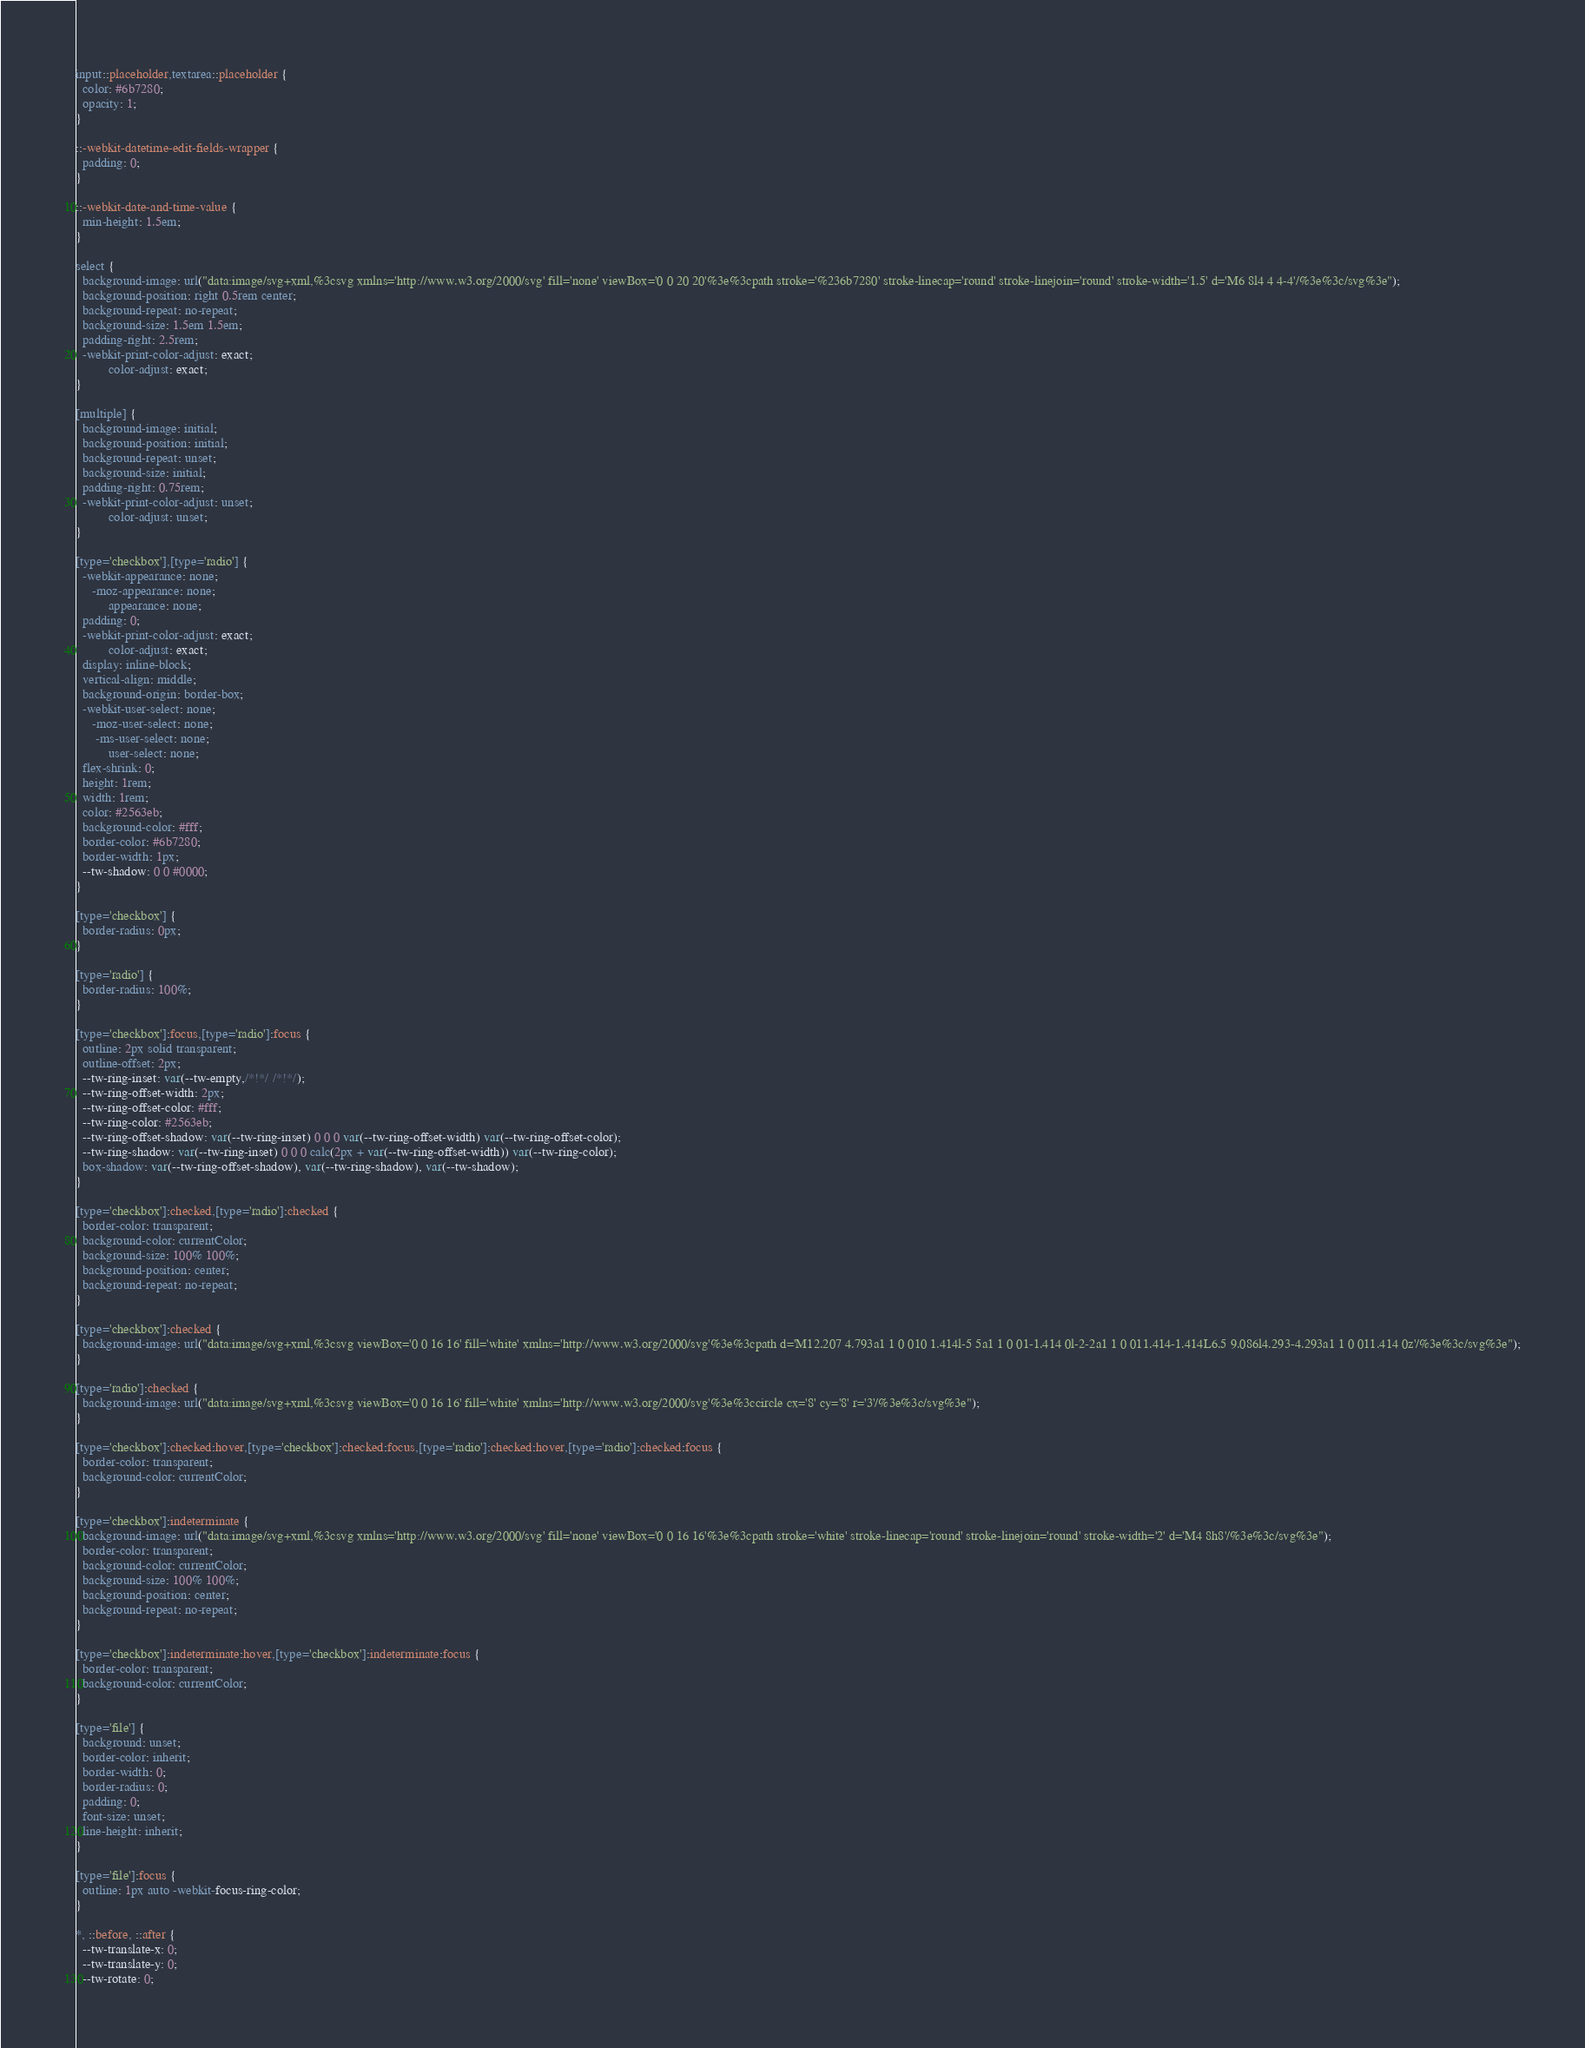Convert code to text. <code><loc_0><loc_0><loc_500><loc_500><_CSS_>
input::placeholder,textarea::placeholder {
  color: #6b7280;
  opacity: 1;
}

::-webkit-datetime-edit-fields-wrapper {
  padding: 0;
}

::-webkit-date-and-time-value {
  min-height: 1.5em;
}

select {
  background-image: url("data:image/svg+xml,%3csvg xmlns='http://www.w3.org/2000/svg' fill='none' viewBox='0 0 20 20'%3e%3cpath stroke='%236b7280' stroke-linecap='round' stroke-linejoin='round' stroke-width='1.5' d='M6 8l4 4 4-4'/%3e%3c/svg%3e");
  background-position: right 0.5rem center;
  background-repeat: no-repeat;
  background-size: 1.5em 1.5em;
  padding-right: 2.5rem;
  -webkit-print-color-adjust: exact;
          color-adjust: exact;
}

[multiple] {
  background-image: initial;
  background-position: initial;
  background-repeat: unset;
  background-size: initial;
  padding-right: 0.75rem;
  -webkit-print-color-adjust: unset;
          color-adjust: unset;
}

[type='checkbox'],[type='radio'] {
  -webkit-appearance: none;
     -moz-appearance: none;
          appearance: none;
  padding: 0;
  -webkit-print-color-adjust: exact;
          color-adjust: exact;
  display: inline-block;
  vertical-align: middle;
  background-origin: border-box;
  -webkit-user-select: none;
     -moz-user-select: none;
      -ms-user-select: none;
          user-select: none;
  flex-shrink: 0;
  height: 1rem;
  width: 1rem;
  color: #2563eb;
  background-color: #fff;
  border-color: #6b7280;
  border-width: 1px;
  --tw-shadow: 0 0 #0000;
}

[type='checkbox'] {
  border-radius: 0px;
}

[type='radio'] {
  border-radius: 100%;
}

[type='checkbox']:focus,[type='radio']:focus {
  outline: 2px solid transparent;
  outline-offset: 2px;
  --tw-ring-inset: var(--tw-empty,/*!*/ /*!*/);
  --tw-ring-offset-width: 2px;
  --tw-ring-offset-color: #fff;
  --tw-ring-color: #2563eb;
  --tw-ring-offset-shadow: var(--tw-ring-inset) 0 0 0 var(--tw-ring-offset-width) var(--tw-ring-offset-color);
  --tw-ring-shadow: var(--tw-ring-inset) 0 0 0 calc(2px + var(--tw-ring-offset-width)) var(--tw-ring-color);
  box-shadow: var(--tw-ring-offset-shadow), var(--tw-ring-shadow), var(--tw-shadow);
}

[type='checkbox']:checked,[type='radio']:checked {
  border-color: transparent;
  background-color: currentColor;
  background-size: 100% 100%;
  background-position: center;
  background-repeat: no-repeat;
}

[type='checkbox']:checked {
  background-image: url("data:image/svg+xml,%3csvg viewBox='0 0 16 16' fill='white' xmlns='http://www.w3.org/2000/svg'%3e%3cpath d='M12.207 4.793a1 1 0 010 1.414l-5 5a1 1 0 01-1.414 0l-2-2a1 1 0 011.414-1.414L6.5 9.086l4.293-4.293a1 1 0 011.414 0z'/%3e%3c/svg%3e");
}

[type='radio']:checked {
  background-image: url("data:image/svg+xml,%3csvg viewBox='0 0 16 16' fill='white' xmlns='http://www.w3.org/2000/svg'%3e%3ccircle cx='8' cy='8' r='3'/%3e%3c/svg%3e");
}

[type='checkbox']:checked:hover,[type='checkbox']:checked:focus,[type='radio']:checked:hover,[type='radio']:checked:focus {
  border-color: transparent;
  background-color: currentColor;
}

[type='checkbox']:indeterminate {
  background-image: url("data:image/svg+xml,%3csvg xmlns='http://www.w3.org/2000/svg' fill='none' viewBox='0 0 16 16'%3e%3cpath stroke='white' stroke-linecap='round' stroke-linejoin='round' stroke-width='2' d='M4 8h8'/%3e%3c/svg%3e");
  border-color: transparent;
  background-color: currentColor;
  background-size: 100% 100%;
  background-position: center;
  background-repeat: no-repeat;
}

[type='checkbox']:indeterminate:hover,[type='checkbox']:indeterminate:focus {
  border-color: transparent;
  background-color: currentColor;
}

[type='file'] {
  background: unset;
  border-color: inherit;
  border-width: 0;
  border-radius: 0;
  padding: 0;
  font-size: unset;
  line-height: inherit;
}

[type='file']:focus {
  outline: 1px auto -webkit-focus-ring-color;
}

*, ::before, ::after {
  --tw-translate-x: 0;
  --tw-translate-y: 0;
  --tw-rotate: 0;</code> 